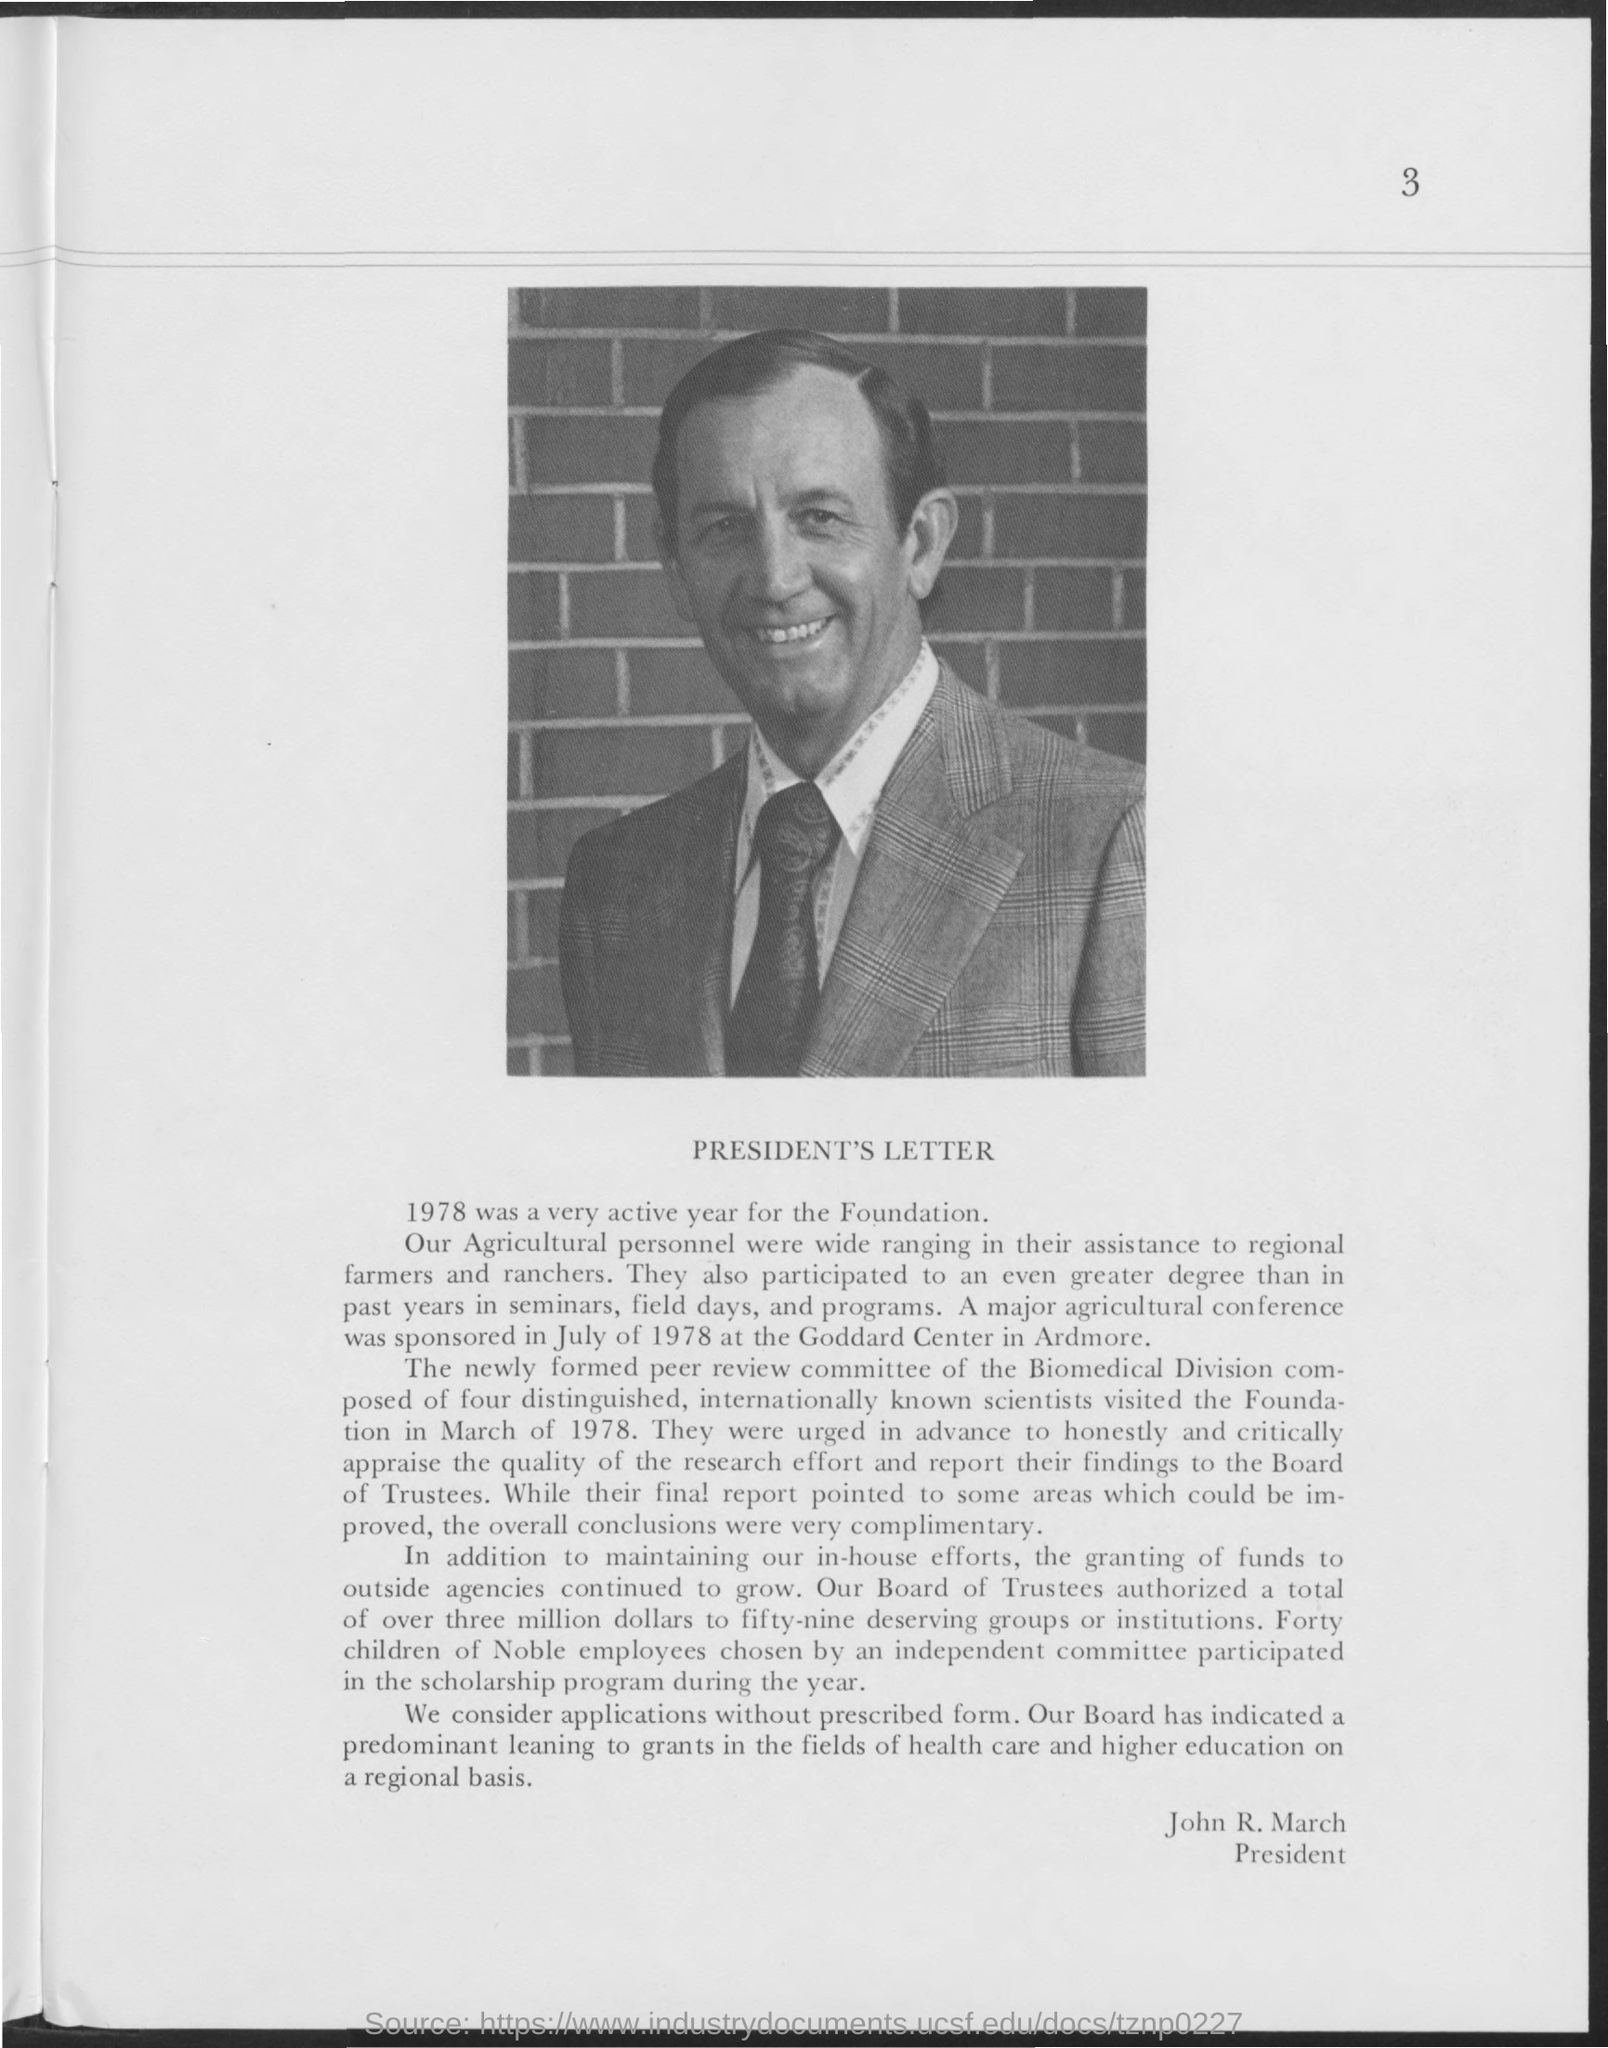What is the heading of the document?
Keep it short and to the point. President's Letter. Who is the author of this letter?
Keep it short and to the point. John R. March. 